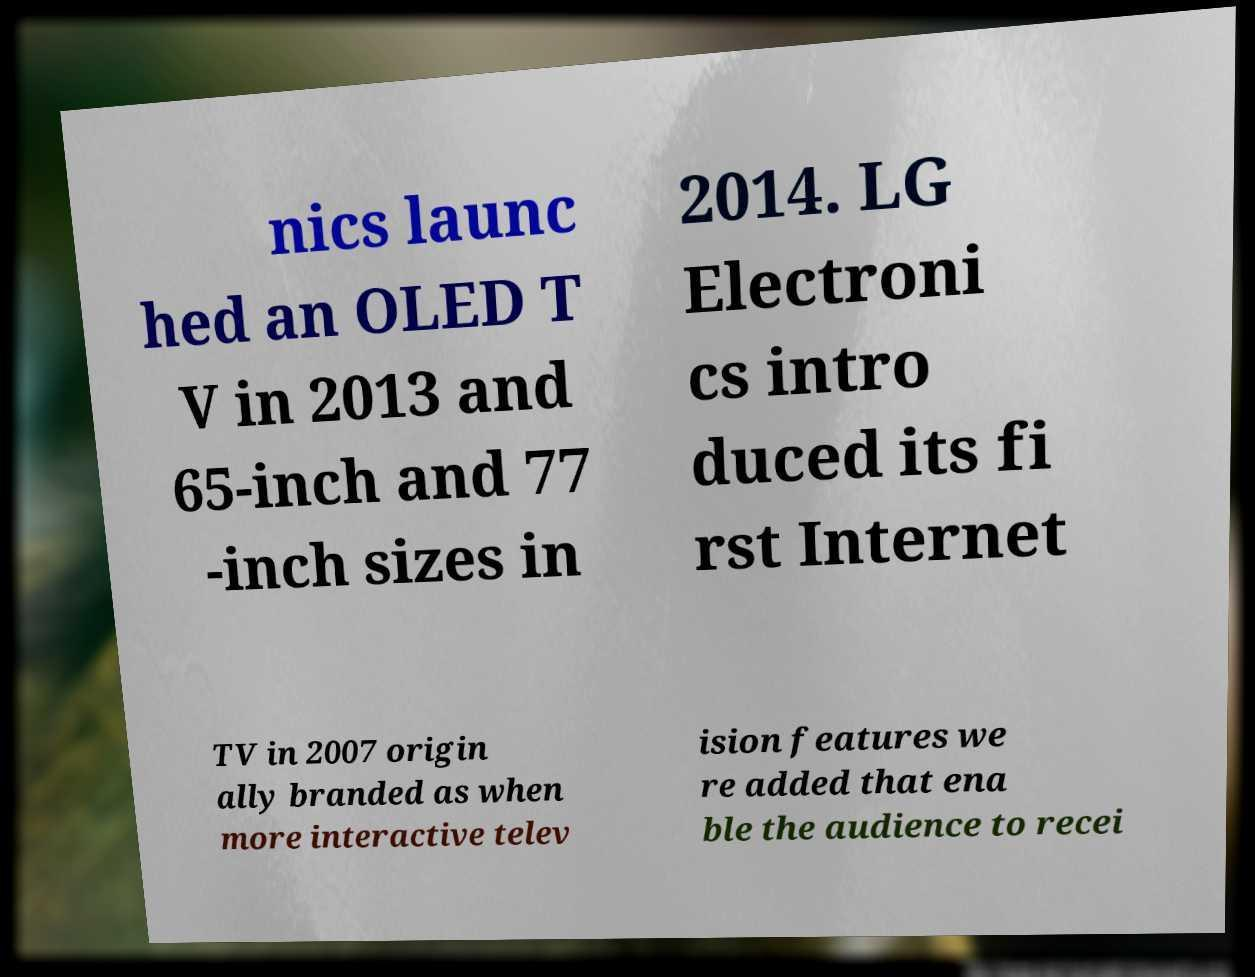For documentation purposes, I need the text within this image transcribed. Could you provide that? nics launc hed an OLED T V in 2013 and 65-inch and 77 -inch sizes in 2014. LG Electroni cs intro duced its fi rst Internet TV in 2007 origin ally branded as when more interactive telev ision features we re added that ena ble the audience to recei 